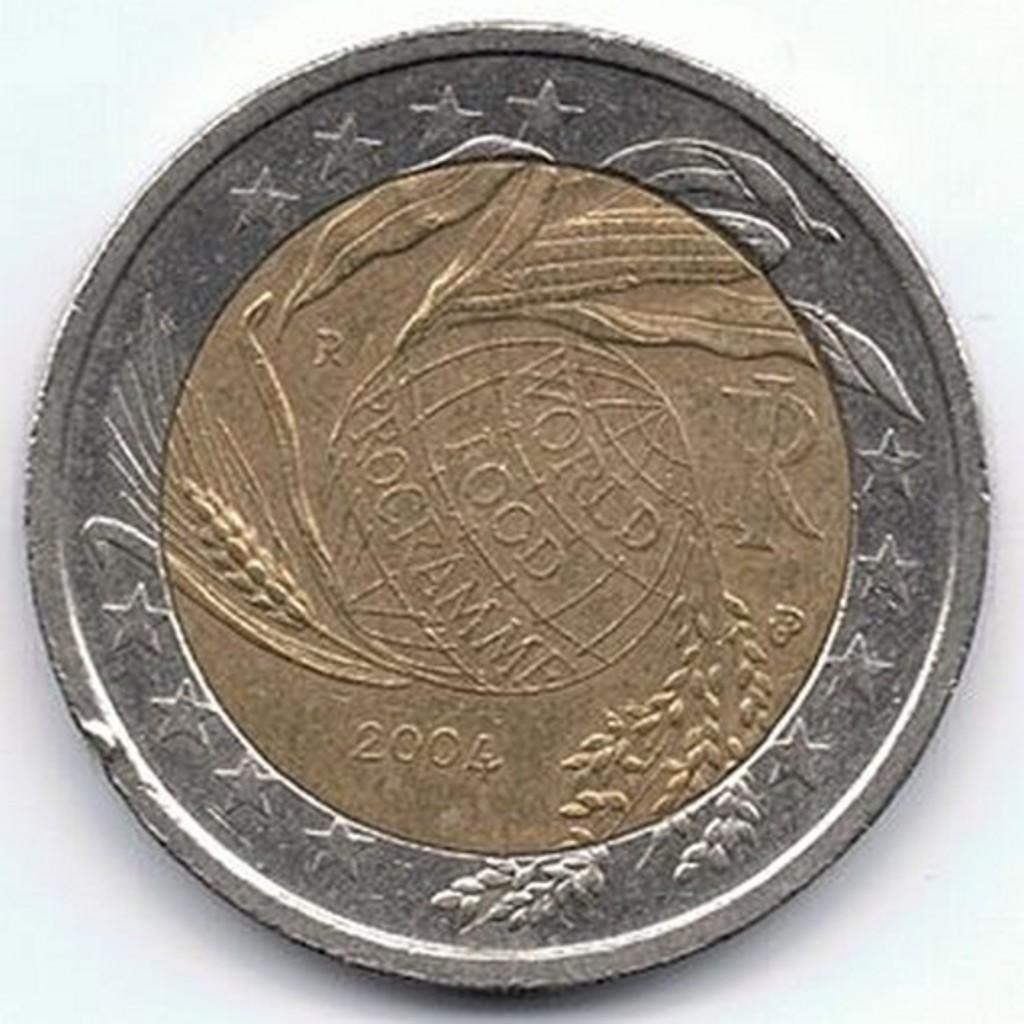What year was this coin made?
Your response must be concise. 2004. What year was this coin made?
Offer a very short reply. 2004. 